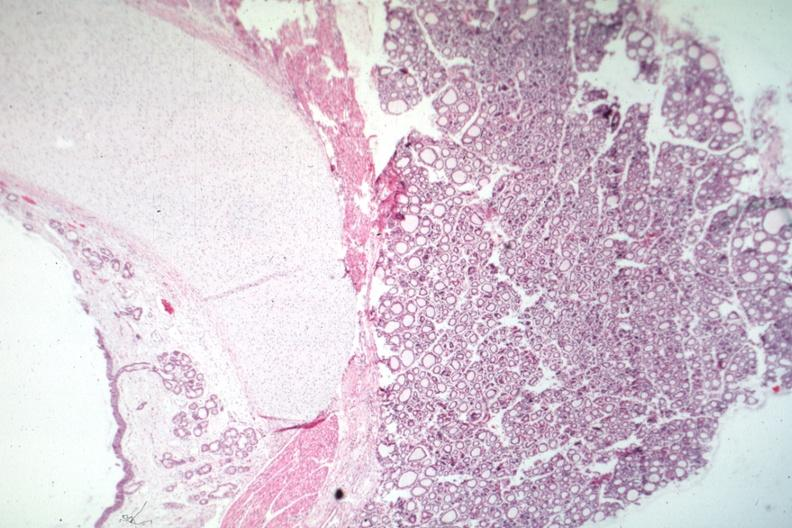s normal immature infant present?
Answer the question using a single word or phrase. Yes 